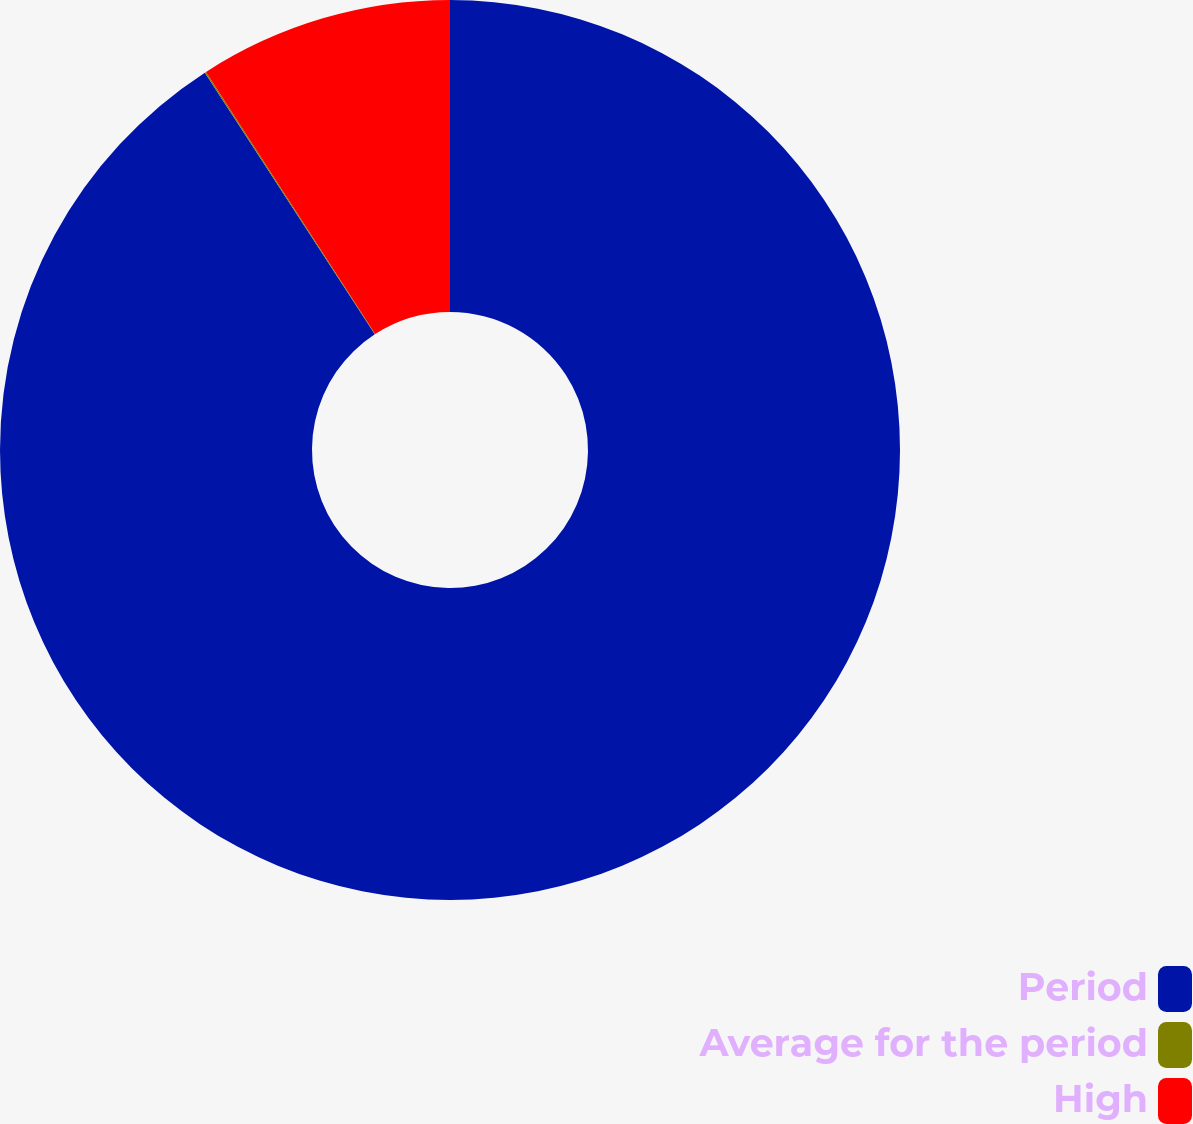<chart> <loc_0><loc_0><loc_500><loc_500><pie_chart><fcel>Period<fcel>Average for the period<fcel>High<nl><fcel>90.83%<fcel>0.05%<fcel>9.12%<nl></chart> 